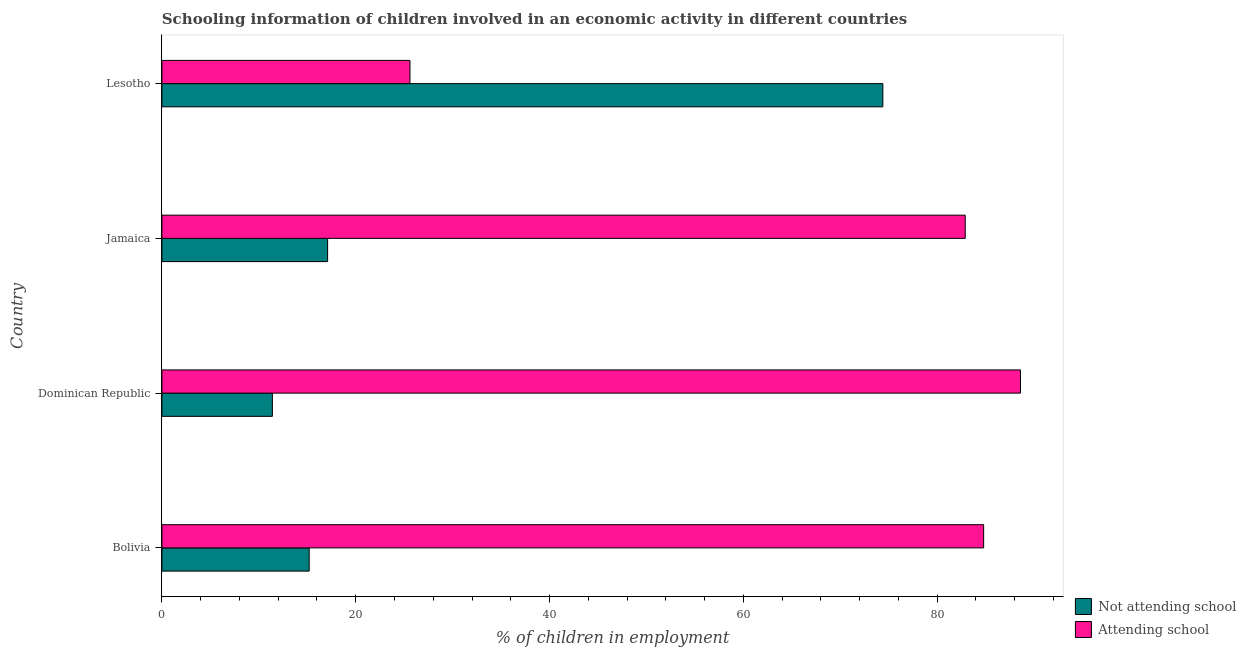How many bars are there on the 1st tick from the top?
Offer a very short reply. 2. What is the label of the 3rd group of bars from the top?
Your response must be concise. Dominican Republic. What is the percentage of employed children who are attending school in Dominican Republic?
Ensure brevity in your answer.  88.6. Across all countries, what is the maximum percentage of employed children who are attending school?
Your response must be concise. 88.6. In which country was the percentage of employed children who are not attending school maximum?
Provide a succinct answer. Lesotho. In which country was the percentage of employed children who are attending school minimum?
Your answer should be very brief. Lesotho. What is the total percentage of employed children who are not attending school in the graph?
Keep it short and to the point. 118.1. What is the difference between the percentage of employed children who are not attending school in Bolivia and that in Jamaica?
Your answer should be compact. -1.9. What is the average percentage of employed children who are attending school per country?
Your response must be concise. 70.47. What is the difference between the percentage of employed children who are attending school and percentage of employed children who are not attending school in Jamaica?
Keep it short and to the point. 65.8. What is the ratio of the percentage of employed children who are not attending school in Dominican Republic to that in Lesotho?
Make the answer very short. 0.15. Is the percentage of employed children who are not attending school in Bolivia less than that in Lesotho?
Provide a succinct answer. Yes. Is the difference between the percentage of employed children who are not attending school in Bolivia and Lesotho greater than the difference between the percentage of employed children who are attending school in Bolivia and Lesotho?
Your response must be concise. No. In how many countries, is the percentage of employed children who are attending school greater than the average percentage of employed children who are attending school taken over all countries?
Your response must be concise. 3. What does the 1st bar from the top in Jamaica represents?
Your answer should be very brief. Attending school. What does the 1st bar from the bottom in Bolivia represents?
Ensure brevity in your answer.  Not attending school. Are all the bars in the graph horizontal?
Your answer should be very brief. Yes. How many countries are there in the graph?
Your response must be concise. 4. What is the difference between two consecutive major ticks on the X-axis?
Your response must be concise. 20. Where does the legend appear in the graph?
Provide a succinct answer. Bottom right. How are the legend labels stacked?
Your response must be concise. Vertical. What is the title of the graph?
Provide a short and direct response. Schooling information of children involved in an economic activity in different countries. Does "Highest 10% of population" appear as one of the legend labels in the graph?
Your answer should be compact. No. What is the label or title of the X-axis?
Offer a terse response. % of children in employment. What is the label or title of the Y-axis?
Your answer should be very brief. Country. What is the % of children in employment in Not attending school in Bolivia?
Provide a succinct answer. 15.2. What is the % of children in employment in Attending school in Bolivia?
Make the answer very short. 84.8. What is the % of children in employment in Not attending school in Dominican Republic?
Ensure brevity in your answer.  11.4. What is the % of children in employment of Attending school in Dominican Republic?
Keep it short and to the point. 88.6. What is the % of children in employment of Not attending school in Jamaica?
Provide a short and direct response. 17.1. What is the % of children in employment of Attending school in Jamaica?
Offer a very short reply. 82.9. What is the % of children in employment in Not attending school in Lesotho?
Keep it short and to the point. 74.4. What is the % of children in employment in Attending school in Lesotho?
Provide a succinct answer. 25.6. Across all countries, what is the maximum % of children in employment in Not attending school?
Your answer should be very brief. 74.4. Across all countries, what is the maximum % of children in employment of Attending school?
Make the answer very short. 88.6. Across all countries, what is the minimum % of children in employment in Attending school?
Keep it short and to the point. 25.6. What is the total % of children in employment of Not attending school in the graph?
Ensure brevity in your answer.  118.1. What is the total % of children in employment of Attending school in the graph?
Keep it short and to the point. 281.9. What is the difference between the % of children in employment of Attending school in Bolivia and that in Dominican Republic?
Provide a succinct answer. -3.8. What is the difference between the % of children in employment of Attending school in Bolivia and that in Jamaica?
Give a very brief answer. 1.9. What is the difference between the % of children in employment of Not attending school in Bolivia and that in Lesotho?
Make the answer very short. -59.2. What is the difference between the % of children in employment in Attending school in Bolivia and that in Lesotho?
Your answer should be very brief. 59.2. What is the difference between the % of children in employment of Attending school in Dominican Republic and that in Jamaica?
Give a very brief answer. 5.7. What is the difference between the % of children in employment of Not attending school in Dominican Republic and that in Lesotho?
Your answer should be compact. -63. What is the difference between the % of children in employment in Not attending school in Jamaica and that in Lesotho?
Offer a very short reply. -57.3. What is the difference between the % of children in employment in Attending school in Jamaica and that in Lesotho?
Ensure brevity in your answer.  57.3. What is the difference between the % of children in employment of Not attending school in Bolivia and the % of children in employment of Attending school in Dominican Republic?
Your answer should be compact. -73.4. What is the difference between the % of children in employment in Not attending school in Bolivia and the % of children in employment in Attending school in Jamaica?
Provide a succinct answer. -67.7. What is the difference between the % of children in employment of Not attending school in Bolivia and the % of children in employment of Attending school in Lesotho?
Give a very brief answer. -10.4. What is the difference between the % of children in employment of Not attending school in Dominican Republic and the % of children in employment of Attending school in Jamaica?
Offer a very short reply. -71.5. What is the difference between the % of children in employment in Not attending school in Dominican Republic and the % of children in employment in Attending school in Lesotho?
Ensure brevity in your answer.  -14.2. What is the difference between the % of children in employment of Not attending school in Jamaica and the % of children in employment of Attending school in Lesotho?
Keep it short and to the point. -8.5. What is the average % of children in employment of Not attending school per country?
Offer a terse response. 29.52. What is the average % of children in employment in Attending school per country?
Keep it short and to the point. 70.47. What is the difference between the % of children in employment of Not attending school and % of children in employment of Attending school in Bolivia?
Make the answer very short. -69.6. What is the difference between the % of children in employment in Not attending school and % of children in employment in Attending school in Dominican Republic?
Give a very brief answer. -77.2. What is the difference between the % of children in employment of Not attending school and % of children in employment of Attending school in Jamaica?
Ensure brevity in your answer.  -65.8. What is the difference between the % of children in employment of Not attending school and % of children in employment of Attending school in Lesotho?
Your answer should be very brief. 48.8. What is the ratio of the % of children in employment in Attending school in Bolivia to that in Dominican Republic?
Ensure brevity in your answer.  0.96. What is the ratio of the % of children in employment of Attending school in Bolivia to that in Jamaica?
Give a very brief answer. 1.02. What is the ratio of the % of children in employment in Not attending school in Bolivia to that in Lesotho?
Offer a very short reply. 0.2. What is the ratio of the % of children in employment in Attending school in Bolivia to that in Lesotho?
Ensure brevity in your answer.  3.31. What is the ratio of the % of children in employment of Not attending school in Dominican Republic to that in Jamaica?
Make the answer very short. 0.67. What is the ratio of the % of children in employment of Attending school in Dominican Republic to that in Jamaica?
Ensure brevity in your answer.  1.07. What is the ratio of the % of children in employment of Not attending school in Dominican Republic to that in Lesotho?
Provide a succinct answer. 0.15. What is the ratio of the % of children in employment of Attending school in Dominican Republic to that in Lesotho?
Make the answer very short. 3.46. What is the ratio of the % of children in employment in Not attending school in Jamaica to that in Lesotho?
Your answer should be compact. 0.23. What is the ratio of the % of children in employment of Attending school in Jamaica to that in Lesotho?
Provide a succinct answer. 3.24. What is the difference between the highest and the second highest % of children in employment of Not attending school?
Your answer should be very brief. 57.3. What is the difference between the highest and the second highest % of children in employment in Attending school?
Offer a terse response. 3.8. What is the difference between the highest and the lowest % of children in employment in Attending school?
Offer a very short reply. 63. 